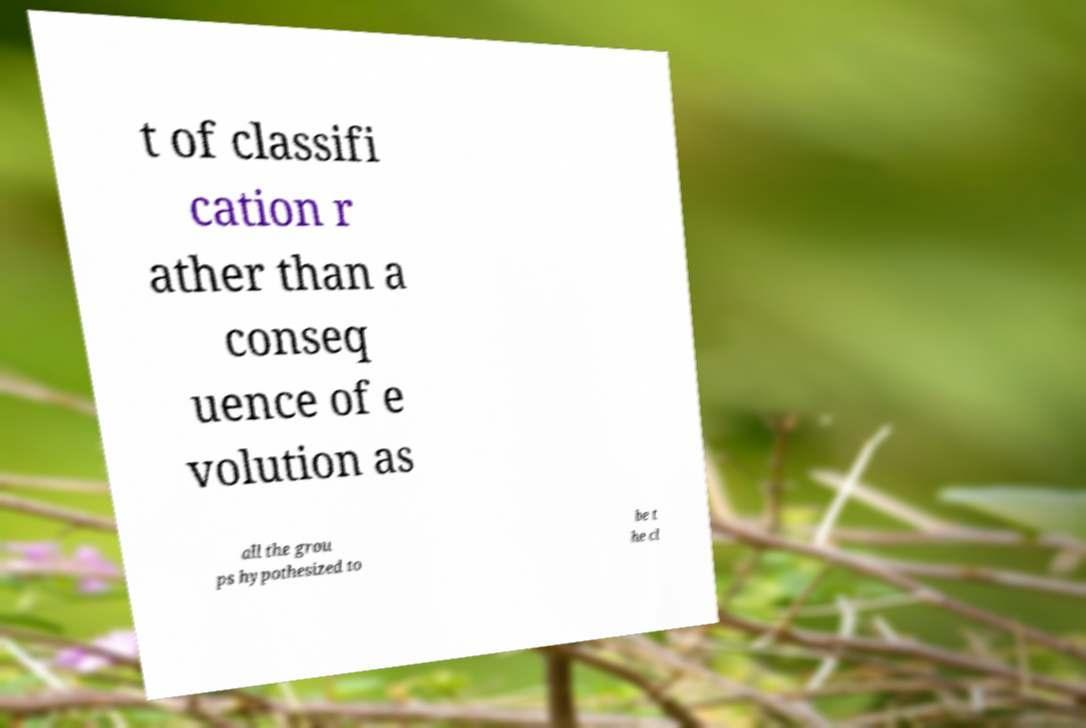I need the written content from this picture converted into text. Can you do that? t of classifi cation r ather than a conseq uence of e volution as all the grou ps hypothesized to be t he cl 